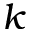<formula> <loc_0><loc_0><loc_500><loc_500>k</formula> 